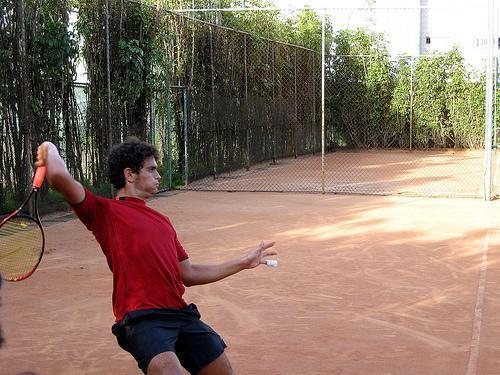How many racket the man is holding?
Give a very brief answer. 1. 